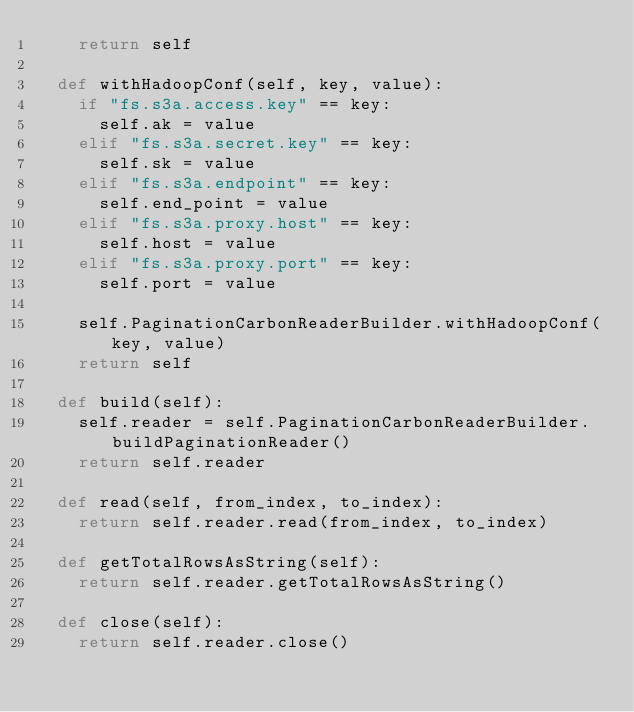Convert code to text. <code><loc_0><loc_0><loc_500><loc_500><_Python_>    return self

  def withHadoopConf(self, key, value):
    if "fs.s3a.access.key" == key:
      self.ak = value
    elif "fs.s3a.secret.key" == key:
      self.sk = value
    elif "fs.s3a.endpoint" == key:
      self.end_point = value
    elif "fs.s3a.proxy.host" == key:
      self.host = value
    elif "fs.s3a.proxy.port" == key:
      self.port = value

    self.PaginationCarbonReaderBuilder.withHadoopConf(key, value)
    return self

  def build(self):
    self.reader = self.PaginationCarbonReaderBuilder.buildPaginationReader()
    return self.reader

  def read(self, from_index, to_index):
    return self.reader.read(from_index, to_index)

  def getTotalRowsAsString(self):
    return self.reader.getTotalRowsAsString()

  def close(self):
    return self.reader.close()

</code> 